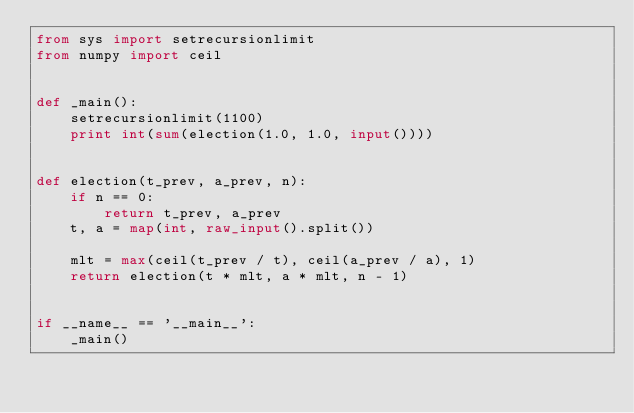<code> <loc_0><loc_0><loc_500><loc_500><_Python_>from sys import setrecursionlimit
from numpy import ceil


def _main():
    setrecursionlimit(1100)
    print int(sum(election(1.0, 1.0, input())))


def election(t_prev, a_prev, n):
    if n == 0:
        return t_prev, a_prev
    t, a = map(int, raw_input().split())

    mlt = max(ceil(t_prev / t), ceil(a_prev / a), 1)
    return election(t * mlt, a * mlt, n - 1)


if __name__ == '__main__':
    _main()</code> 